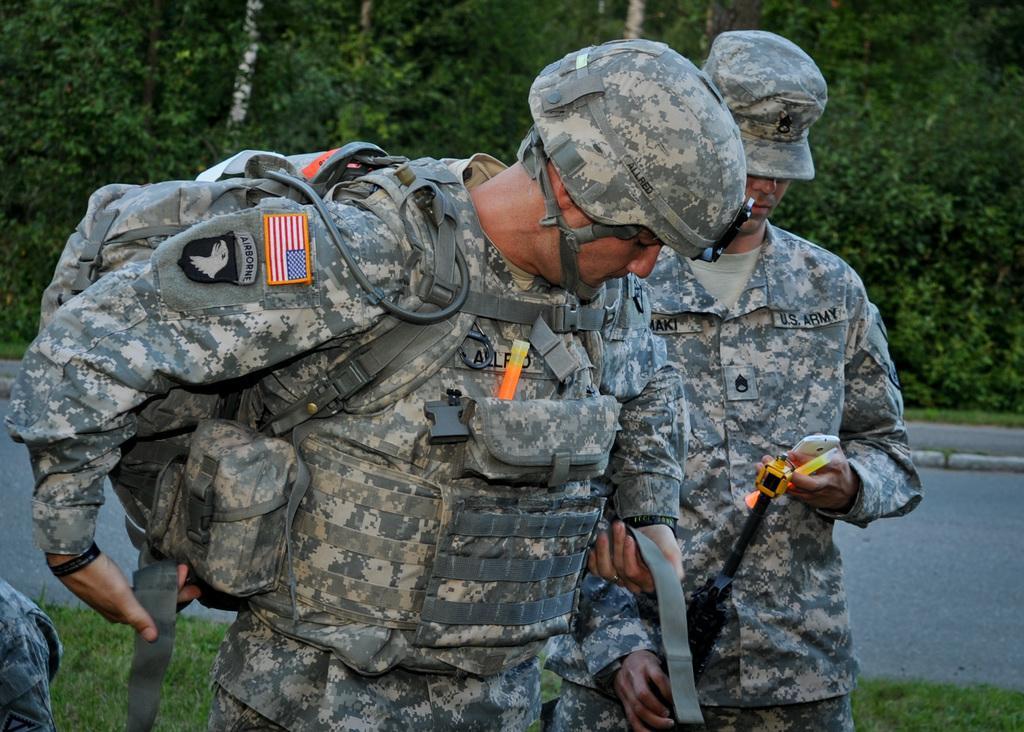In one or two sentences, can you explain what this image depicts? In the center of the image we can see a man is standing and wearing cap and carrying a bag, beside him another man is standing and wearing cap and holding a gun, mobile and object. In the background of the image we can see the trees. In the middle of the image we can see the road. At the bottom of the image we can see the grass. 